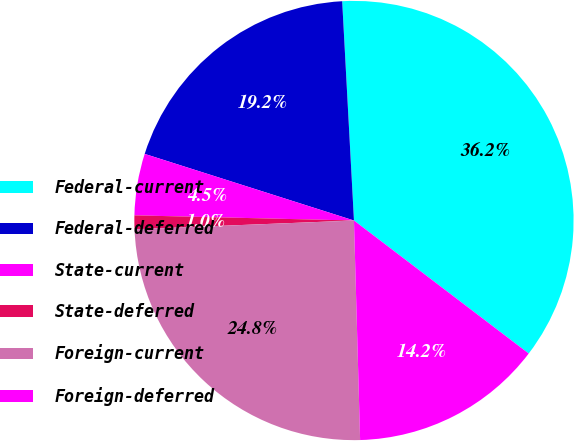Convert chart. <chart><loc_0><loc_0><loc_500><loc_500><pie_chart><fcel>Federal-current<fcel>Federal-deferred<fcel>State-current<fcel>State-deferred<fcel>Foreign-current<fcel>Foreign-deferred<nl><fcel>36.21%<fcel>19.24%<fcel>4.53%<fcel>1.01%<fcel>24.81%<fcel>14.2%<nl></chart> 